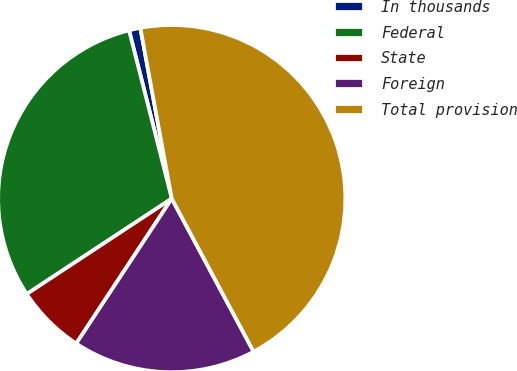Convert chart to OTSL. <chart><loc_0><loc_0><loc_500><loc_500><pie_chart><fcel>In thousands<fcel>Federal<fcel>State<fcel>Foreign<fcel>Total provision<nl><fcel>1.06%<fcel>30.31%<fcel>6.46%<fcel>17.09%<fcel>45.08%<nl></chart> 